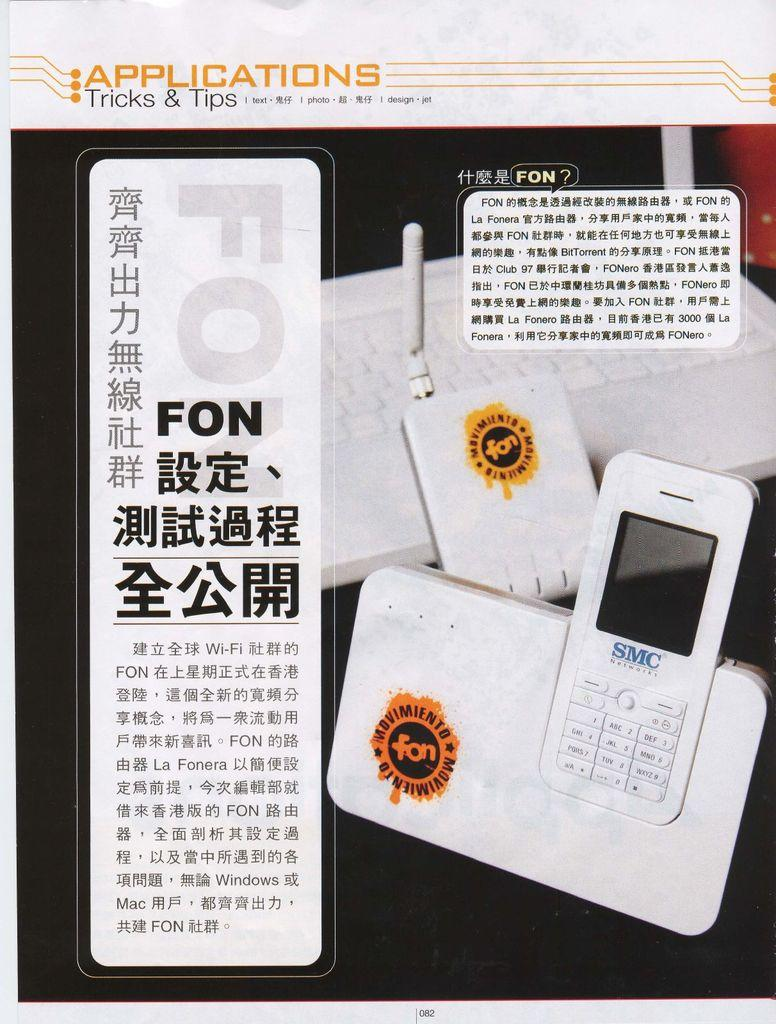<image>
Share a concise interpretation of the image provided. An SMC Networks phone in a charger base. 